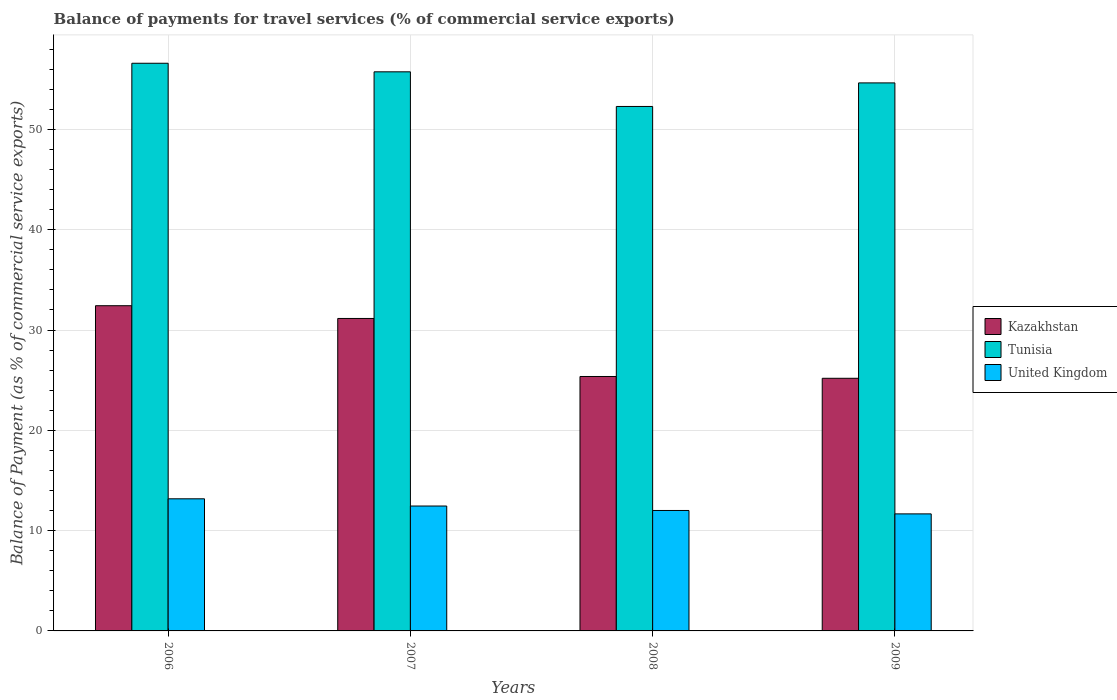How many different coloured bars are there?
Give a very brief answer. 3. How many groups of bars are there?
Make the answer very short. 4. Are the number of bars per tick equal to the number of legend labels?
Your response must be concise. Yes. Are the number of bars on each tick of the X-axis equal?
Offer a very short reply. Yes. What is the balance of payments for travel services in Kazakhstan in 2009?
Offer a terse response. 25.19. Across all years, what is the maximum balance of payments for travel services in United Kingdom?
Offer a very short reply. 13.17. Across all years, what is the minimum balance of payments for travel services in United Kingdom?
Offer a very short reply. 11.67. What is the total balance of payments for travel services in Tunisia in the graph?
Offer a terse response. 219.25. What is the difference between the balance of payments for travel services in Tunisia in 2008 and that in 2009?
Your answer should be very brief. -2.35. What is the difference between the balance of payments for travel services in United Kingdom in 2007 and the balance of payments for travel services in Tunisia in 2009?
Offer a very short reply. -42.18. What is the average balance of payments for travel services in Tunisia per year?
Provide a short and direct response. 54.81. In the year 2006, what is the difference between the balance of payments for travel services in United Kingdom and balance of payments for travel services in Tunisia?
Provide a succinct answer. -43.42. What is the ratio of the balance of payments for travel services in United Kingdom in 2006 to that in 2008?
Provide a succinct answer. 1.1. Is the balance of payments for travel services in United Kingdom in 2007 less than that in 2008?
Keep it short and to the point. No. What is the difference between the highest and the second highest balance of payments for travel services in United Kingdom?
Offer a very short reply. 0.72. What is the difference between the highest and the lowest balance of payments for travel services in United Kingdom?
Your answer should be very brief. 1.5. In how many years, is the balance of payments for travel services in Kazakhstan greater than the average balance of payments for travel services in Kazakhstan taken over all years?
Ensure brevity in your answer.  2. Is the sum of the balance of payments for travel services in Kazakhstan in 2006 and 2008 greater than the maximum balance of payments for travel services in United Kingdom across all years?
Offer a terse response. Yes. What does the 1st bar from the left in 2006 represents?
Give a very brief answer. Kazakhstan. What does the 3rd bar from the right in 2006 represents?
Your answer should be very brief. Kazakhstan. Are all the bars in the graph horizontal?
Give a very brief answer. No. Are the values on the major ticks of Y-axis written in scientific E-notation?
Offer a very short reply. No. Does the graph contain any zero values?
Provide a short and direct response. No. Does the graph contain grids?
Your answer should be compact. Yes. Where does the legend appear in the graph?
Make the answer very short. Center right. What is the title of the graph?
Your answer should be compact. Balance of payments for travel services (% of commercial service exports). Does "Denmark" appear as one of the legend labels in the graph?
Offer a terse response. No. What is the label or title of the Y-axis?
Provide a short and direct response. Balance of Payment (as % of commercial service exports). What is the Balance of Payment (as % of commercial service exports) of Kazakhstan in 2006?
Your answer should be very brief. 32.42. What is the Balance of Payment (as % of commercial service exports) of Tunisia in 2006?
Keep it short and to the point. 56.59. What is the Balance of Payment (as % of commercial service exports) of United Kingdom in 2006?
Keep it short and to the point. 13.17. What is the Balance of Payment (as % of commercial service exports) in Kazakhstan in 2007?
Your answer should be very brief. 31.15. What is the Balance of Payment (as % of commercial service exports) of Tunisia in 2007?
Ensure brevity in your answer.  55.74. What is the Balance of Payment (as % of commercial service exports) in United Kingdom in 2007?
Offer a very short reply. 12.45. What is the Balance of Payment (as % of commercial service exports) in Kazakhstan in 2008?
Provide a short and direct response. 25.37. What is the Balance of Payment (as % of commercial service exports) of Tunisia in 2008?
Make the answer very short. 52.29. What is the Balance of Payment (as % of commercial service exports) in United Kingdom in 2008?
Give a very brief answer. 12.01. What is the Balance of Payment (as % of commercial service exports) of Kazakhstan in 2009?
Offer a very short reply. 25.19. What is the Balance of Payment (as % of commercial service exports) in Tunisia in 2009?
Provide a short and direct response. 54.63. What is the Balance of Payment (as % of commercial service exports) in United Kingdom in 2009?
Give a very brief answer. 11.67. Across all years, what is the maximum Balance of Payment (as % of commercial service exports) in Kazakhstan?
Offer a very short reply. 32.42. Across all years, what is the maximum Balance of Payment (as % of commercial service exports) of Tunisia?
Keep it short and to the point. 56.59. Across all years, what is the maximum Balance of Payment (as % of commercial service exports) of United Kingdom?
Make the answer very short. 13.17. Across all years, what is the minimum Balance of Payment (as % of commercial service exports) in Kazakhstan?
Offer a terse response. 25.19. Across all years, what is the minimum Balance of Payment (as % of commercial service exports) in Tunisia?
Make the answer very short. 52.29. Across all years, what is the minimum Balance of Payment (as % of commercial service exports) in United Kingdom?
Offer a terse response. 11.67. What is the total Balance of Payment (as % of commercial service exports) in Kazakhstan in the graph?
Make the answer very short. 114.12. What is the total Balance of Payment (as % of commercial service exports) in Tunisia in the graph?
Give a very brief answer. 219.25. What is the total Balance of Payment (as % of commercial service exports) in United Kingdom in the graph?
Keep it short and to the point. 49.3. What is the difference between the Balance of Payment (as % of commercial service exports) in Kazakhstan in 2006 and that in 2007?
Your answer should be very brief. 1.27. What is the difference between the Balance of Payment (as % of commercial service exports) of Tunisia in 2006 and that in 2007?
Your answer should be very brief. 0.85. What is the difference between the Balance of Payment (as % of commercial service exports) of United Kingdom in 2006 and that in 2007?
Provide a short and direct response. 0.72. What is the difference between the Balance of Payment (as % of commercial service exports) in Kazakhstan in 2006 and that in 2008?
Your response must be concise. 7.06. What is the difference between the Balance of Payment (as % of commercial service exports) of Tunisia in 2006 and that in 2008?
Give a very brief answer. 4.31. What is the difference between the Balance of Payment (as % of commercial service exports) in United Kingdom in 2006 and that in 2008?
Your response must be concise. 1.16. What is the difference between the Balance of Payment (as % of commercial service exports) of Kazakhstan in 2006 and that in 2009?
Your answer should be compact. 7.23. What is the difference between the Balance of Payment (as % of commercial service exports) in Tunisia in 2006 and that in 2009?
Offer a terse response. 1.96. What is the difference between the Balance of Payment (as % of commercial service exports) in United Kingdom in 2006 and that in 2009?
Keep it short and to the point. 1.5. What is the difference between the Balance of Payment (as % of commercial service exports) of Kazakhstan in 2007 and that in 2008?
Make the answer very short. 5.78. What is the difference between the Balance of Payment (as % of commercial service exports) of Tunisia in 2007 and that in 2008?
Make the answer very short. 3.45. What is the difference between the Balance of Payment (as % of commercial service exports) of United Kingdom in 2007 and that in 2008?
Make the answer very short. 0.44. What is the difference between the Balance of Payment (as % of commercial service exports) of Kazakhstan in 2007 and that in 2009?
Provide a succinct answer. 5.96. What is the difference between the Balance of Payment (as % of commercial service exports) in Tunisia in 2007 and that in 2009?
Ensure brevity in your answer.  1.1. What is the difference between the Balance of Payment (as % of commercial service exports) in United Kingdom in 2007 and that in 2009?
Your answer should be compact. 0.78. What is the difference between the Balance of Payment (as % of commercial service exports) of Kazakhstan in 2008 and that in 2009?
Your response must be concise. 0.18. What is the difference between the Balance of Payment (as % of commercial service exports) of Tunisia in 2008 and that in 2009?
Offer a terse response. -2.35. What is the difference between the Balance of Payment (as % of commercial service exports) in United Kingdom in 2008 and that in 2009?
Provide a succinct answer. 0.34. What is the difference between the Balance of Payment (as % of commercial service exports) of Kazakhstan in 2006 and the Balance of Payment (as % of commercial service exports) of Tunisia in 2007?
Offer a very short reply. -23.32. What is the difference between the Balance of Payment (as % of commercial service exports) of Kazakhstan in 2006 and the Balance of Payment (as % of commercial service exports) of United Kingdom in 2007?
Give a very brief answer. 19.97. What is the difference between the Balance of Payment (as % of commercial service exports) of Tunisia in 2006 and the Balance of Payment (as % of commercial service exports) of United Kingdom in 2007?
Offer a terse response. 44.14. What is the difference between the Balance of Payment (as % of commercial service exports) in Kazakhstan in 2006 and the Balance of Payment (as % of commercial service exports) in Tunisia in 2008?
Give a very brief answer. -19.87. What is the difference between the Balance of Payment (as % of commercial service exports) in Kazakhstan in 2006 and the Balance of Payment (as % of commercial service exports) in United Kingdom in 2008?
Ensure brevity in your answer.  20.41. What is the difference between the Balance of Payment (as % of commercial service exports) in Tunisia in 2006 and the Balance of Payment (as % of commercial service exports) in United Kingdom in 2008?
Offer a very short reply. 44.58. What is the difference between the Balance of Payment (as % of commercial service exports) of Kazakhstan in 2006 and the Balance of Payment (as % of commercial service exports) of Tunisia in 2009?
Your answer should be very brief. -22.21. What is the difference between the Balance of Payment (as % of commercial service exports) in Kazakhstan in 2006 and the Balance of Payment (as % of commercial service exports) in United Kingdom in 2009?
Provide a short and direct response. 20.75. What is the difference between the Balance of Payment (as % of commercial service exports) in Tunisia in 2006 and the Balance of Payment (as % of commercial service exports) in United Kingdom in 2009?
Provide a short and direct response. 44.92. What is the difference between the Balance of Payment (as % of commercial service exports) of Kazakhstan in 2007 and the Balance of Payment (as % of commercial service exports) of Tunisia in 2008?
Your response must be concise. -21.14. What is the difference between the Balance of Payment (as % of commercial service exports) in Kazakhstan in 2007 and the Balance of Payment (as % of commercial service exports) in United Kingdom in 2008?
Give a very brief answer. 19.14. What is the difference between the Balance of Payment (as % of commercial service exports) of Tunisia in 2007 and the Balance of Payment (as % of commercial service exports) of United Kingdom in 2008?
Provide a succinct answer. 43.73. What is the difference between the Balance of Payment (as % of commercial service exports) in Kazakhstan in 2007 and the Balance of Payment (as % of commercial service exports) in Tunisia in 2009?
Your answer should be very brief. -23.48. What is the difference between the Balance of Payment (as % of commercial service exports) in Kazakhstan in 2007 and the Balance of Payment (as % of commercial service exports) in United Kingdom in 2009?
Provide a succinct answer. 19.48. What is the difference between the Balance of Payment (as % of commercial service exports) of Tunisia in 2007 and the Balance of Payment (as % of commercial service exports) of United Kingdom in 2009?
Keep it short and to the point. 44.07. What is the difference between the Balance of Payment (as % of commercial service exports) in Kazakhstan in 2008 and the Balance of Payment (as % of commercial service exports) in Tunisia in 2009?
Offer a terse response. -29.27. What is the difference between the Balance of Payment (as % of commercial service exports) in Kazakhstan in 2008 and the Balance of Payment (as % of commercial service exports) in United Kingdom in 2009?
Your response must be concise. 13.7. What is the difference between the Balance of Payment (as % of commercial service exports) of Tunisia in 2008 and the Balance of Payment (as % of commercial service exports) of United Kingdom in 2009?
Ensure brevity in your answer.  40.62. What is the average Balance of Payment (as % of commercial service exports) in Kazakhstan per year?
Offer a very short reply. 28.53. What is the average Balance of Payment (as % of commercial service exports) of Tunisia per year?
Make the answer very short. 54.81. What is the average Balance of Payment (as % of commercial service exports) of United Kingdom per year?
Your response must be concise. 12.32. In the year 2006, what is the difference between the Balance of Payment (as % of commercial service exports) in Kazakhstan and Balance of Payment (as % of commercial service exports) in Tunisia?
Provide a short and direct response. -24.17. In the year 2006, what is the difference between the Balance of Payment (as % of commercial service exports) in Kazakhstan and Balance of Payment (as % of commercial service exports) in United Kingdom?
Your answer should be very brief. 19.25. In the year 2006, what is the difference between the Balance of Payment (as % of commercial service exports) of Tunisia and Balance of Payment (as % of commercial service exports) of United Kingdom?
Your answer should be very brief. 43.42. In the year 2007, what is the difference between the Balance of Payment (as % of commercial service exports) of Kazakhstan and Balance of Payment (as % of commercial service exports) of Tunisia?
Provide a short and direct response. -24.59. In the year 2007, what is the difference between the Balance of Payment (as % of commercial service exports) of Kazakhstan and Balance of Payment (as % of commercial service exports) of United Kingdom?
Give a very brief answer. 18.7. In the year 2007, what is the difference between the Balance of Payment (as % of commercial service exports) of Tunisia and Balance of Payment (as % of commercial service exports) of United Kingdom?
Ensure brevity in your answer.  43.29. In the year 2008, what is the difference between the Balance of Payment (as % of commercial service exports) of Kazakhstan and Balance of Payment (as % of commercial service exports) of Tunisia?
Your response must be concise. -26.92. In the year 2008, what is the difference between the Balance of Payment (as % of commercial service exports) in Kazakhstan and Balance of Payment (as % of commercial service exports) in United Kingdom?
Give a very brief answer. 13.36. In the year 2008, what is the difference between the Balance of Payment (as % of commercial service exports) of Tunisia and Balance of Payment (as % of commercial service exports) of United Kingdom?
Make the answer very short. 40.28. In the year 2009, what is the difference between the Balance of Payment (as % of commercial service exports) of Kazakhstan and Balance of Payment (as % of commercial service exports) of Tunisia?
Offer a very short reply. -29.45. In the year 2009, what is the difference between the Balance of Payment (as % of commercial service exports) of Kazakhstan and Balance of Payment (as % of commercial service exports) of United Kingdom?
Your response must be concise. 13.52. In the year 2009, what is the difference between the Balance of Payment (as % of commercial service exports) in Tunisia and Balance of Payment (as % of commercial service exports) in United Kingdom?
Your answer should be compact. 42.97. What is the ratio of the Balance of Payment (as % of commercial service exports) of Kazakhstan in 2006 to that in 2007?
Give a very brief answer. 1.04. What is the ratio of the Balance of Payment (as % of commercial service exports) in Tunisia in 2006 to that in 2007?
Keep it short and to the point. 1.02. What is the ratio of the Balance of Payment (as % of commercial service exports) in United Kingdom in 2006 to that in 2007?
Provide a succinct answer. 1.06. What is the ratio of the Balance of Payment (as % of commercial service exports) in Kazakhstan in 2006 to that in 2008?
Offer a terse response. 1.28. What is the ratio of the Balance of Payment (as % of commercial service exports) in Tunisia in 2006 to that in 2008?
Provide a succinct answer. 1.08. What is the ratio of the Balance of Payment (as % of commercial service exports) in United Kingdom in 2006 to that in 2008?
Your answer should be compact. 1.1. What is the ratio of the Balance of Payment (as % of commercial service exports) of Kazakhstan in 2006 to that in 2009?
Keep it short and to the point. 1.29. What is the ratio of the Balance of Payment (as % of commercial service exports) of Tunisia in 2006 to that in 2009?
Make the answer very short. 1.04. What is the ratio of the Balance of Payment (as % of commercial service exports) of United Kingdom in 2006 to that in 2009?
Offer a terse response. 1.13. What is the ratio of the Balance of Payment (as % of commercial service exports) in Kazakhstan in 2007 to that in 2008?
Your answer should be very brief. 1.23. What is the ratio of the Balance of Payment (as % of commercial service exports) in Tunisia in 2007 to that in 2008?
Offer a terse response. 1.07. What is the ratio of the Balance of Payment (as % of commercial service exports) in United Kingdom in 2007 to that in 2008?
Your answer should be compact. 1.04. What is the ratio of the Balance of Payment (as % of commercial service exports) in Kazakhstan in 2007 to that in 2009?
Your response must be concise. 1.24. What is the ratio of the Balance of Payment (as % of commercial service exports) of Tunisia in 2007 to that in 2009?
Keep it short and to the point. 1.02. What is the ratio of the Balance of Payment (as % of commercial service exports) of United Kingdom in 2007 to that in 2009?
Offer a very short reply. 1.07. What is the ratio of the Balance of Payment (as % of commercial service exports) of Kazakhstan in 2008 to that in 2009?
Offer a terse response. 1.01. What is the ratio of the Balance of Payment (as % of commercial service exports) in Tunisia in 2008 to that in 2009?
Make the answer very short. 0.96. What is the ratio of the Balance of Payment (as % of commercial service exports) in United Kingdom in 2008 to that in 2009?
Make the answer very short. 1.03. What is the difference between the highest and the second highest Balance of Payment (as % of commercial service exports) of Kazakhstan?
Offer a terse response. 1.27. What is the difference between the highest and the second highest Balance of Payment (as % of commercial service exports) of Tunisia?
Ensure brevity in your answer.  0.85. What is the difference between the highest and the second highest Balance of Payment (as % of commercial service exports) in United Kingdom?
Keep it short and to the point. 0.72. What is the difference between the highest and the lowest Balance of Payment (as % of commercial service exports) in Kazakhstan?
Offer a very short reply. 7.23. What is the difference between the highest and the lowest Balance of Payment (as % of commercial service exports) of Tunisia?
Provide a succinct answer. 4.31. What is the difference between the highest and the lowest Balance of Payment (as % of commercial service exports) in United Kingdom?
Offer a terse response. 1.5. 